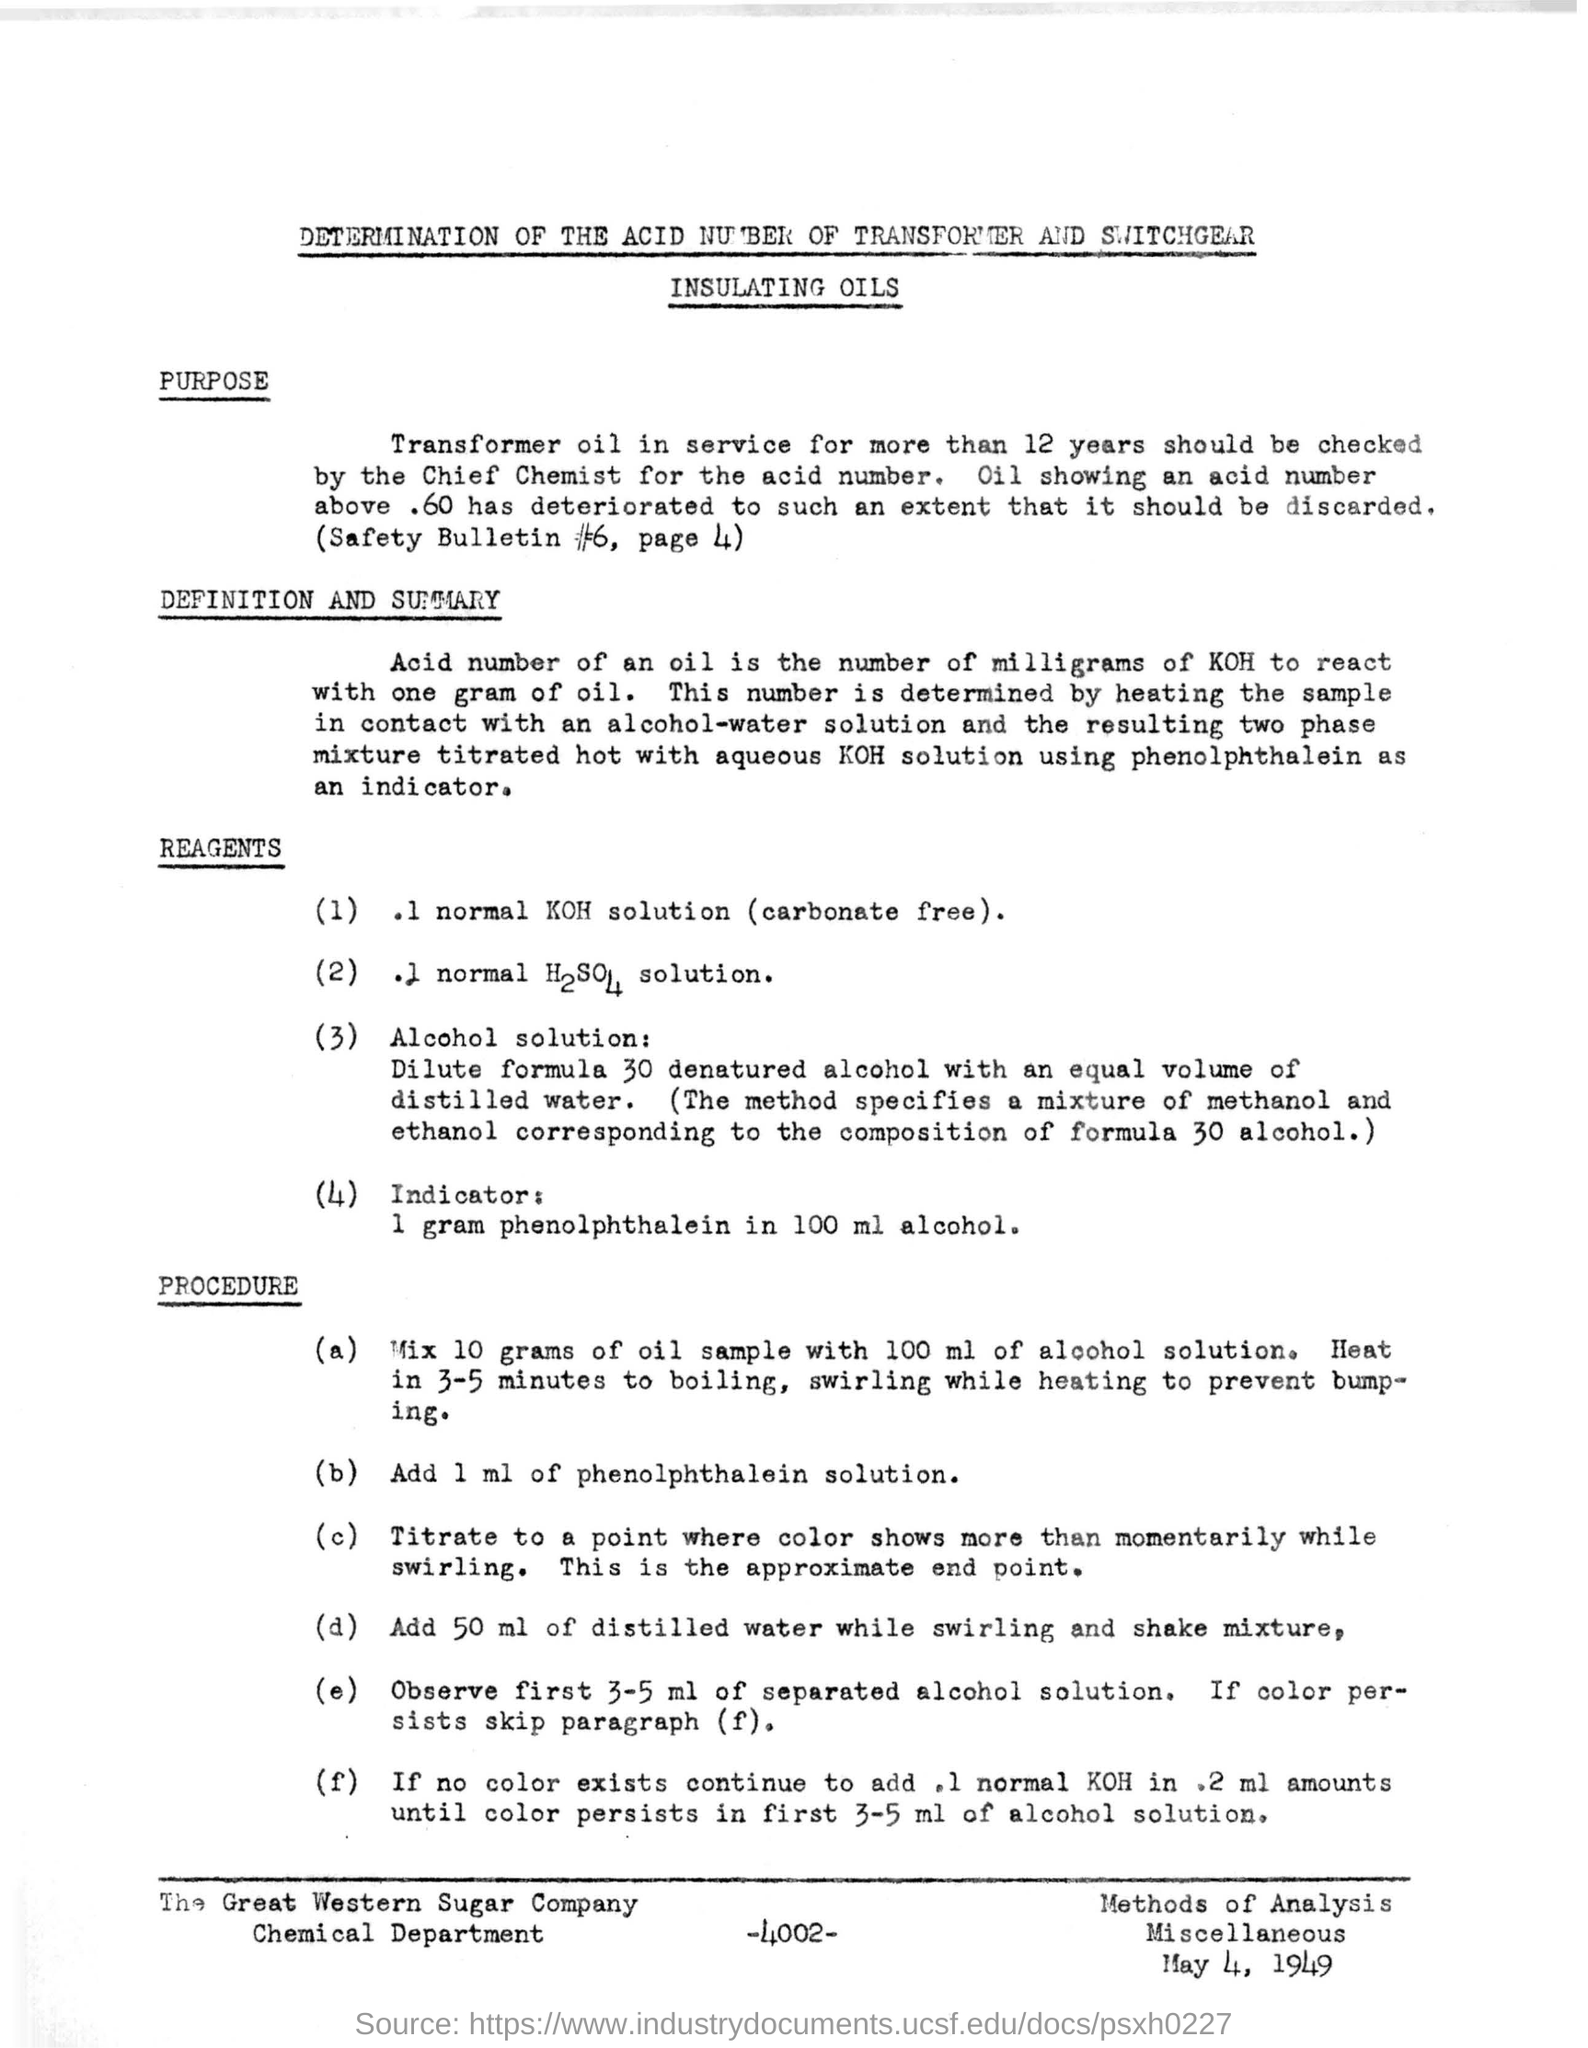What is written in the top of the document ?
Offer a very short reply. DETERMINATION OF THE ACID NUMBER OF TRANSFORMER AND SWITCHGEAR INSULATING OILS. What is the date mentioned in the bottom of the document ?
Make the answer very short. May 4, 1949. What is the number written in the bottom of the document ?
Your answer should be compact. -4002-. What is the company name written in the bottom of the document ?
Provide a succinct answer. The Great Western Sugar Company. 